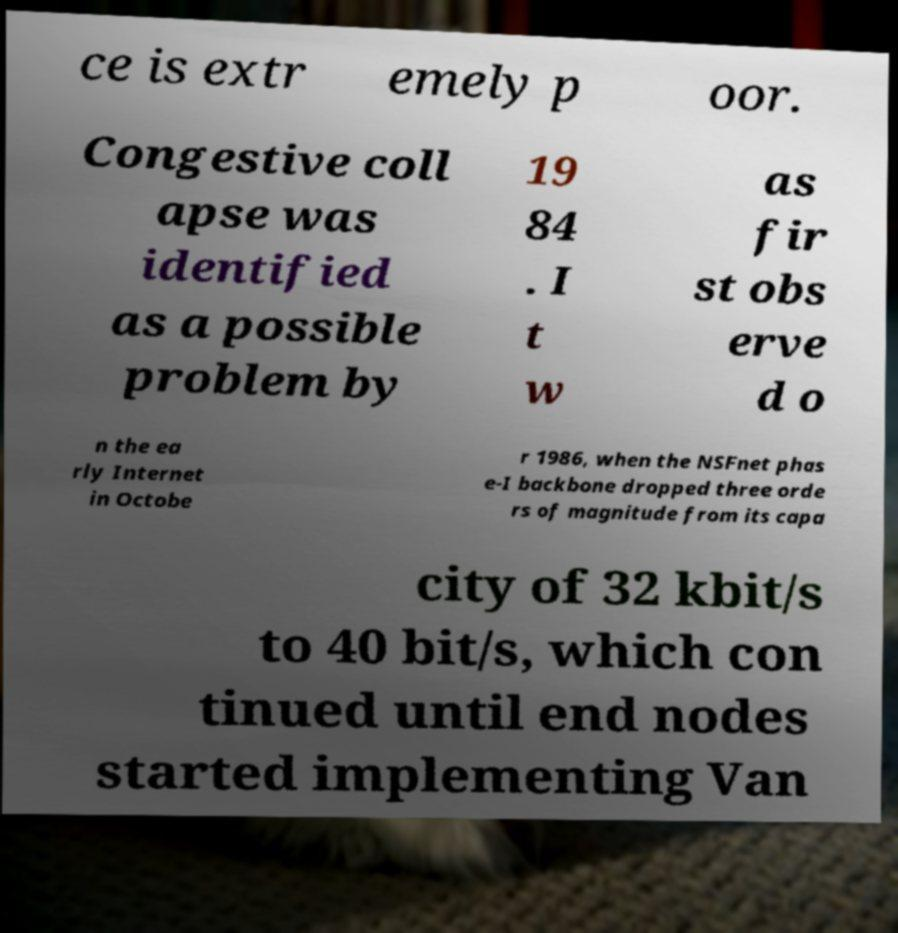Please read and relay the text visible in this image. What does it say? ce is extr emely p oor. Congestive coll apse was identified as a possible problem by 19 84 . I t w as fir st obs erve d o n the ea rly Internet in Octobe r 1986, when the NSFnet phas e-I backbone dropped three orde rs of magnitude from its capa city of 32 kbit/s to 40 bit/s, which con tinued until end nodes started implementing Van 